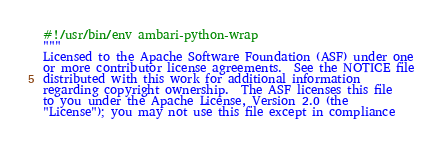Convert code to text. <code><loc_0><loc_0><loc_500><loc_500><_Python_>#!/usr/bin/env ambari-python-wrap
"""
Licensed to the Apache Software Foundation (ASF) under one
or more contributor license agreements.  See the NOTICE file
distributed with this work for additional information
regarding copyright ownership.  The ASF licenses this file
to you under the Apache License, Version 2.0 (the
"License"); you may not use this file except in compliance</code> 